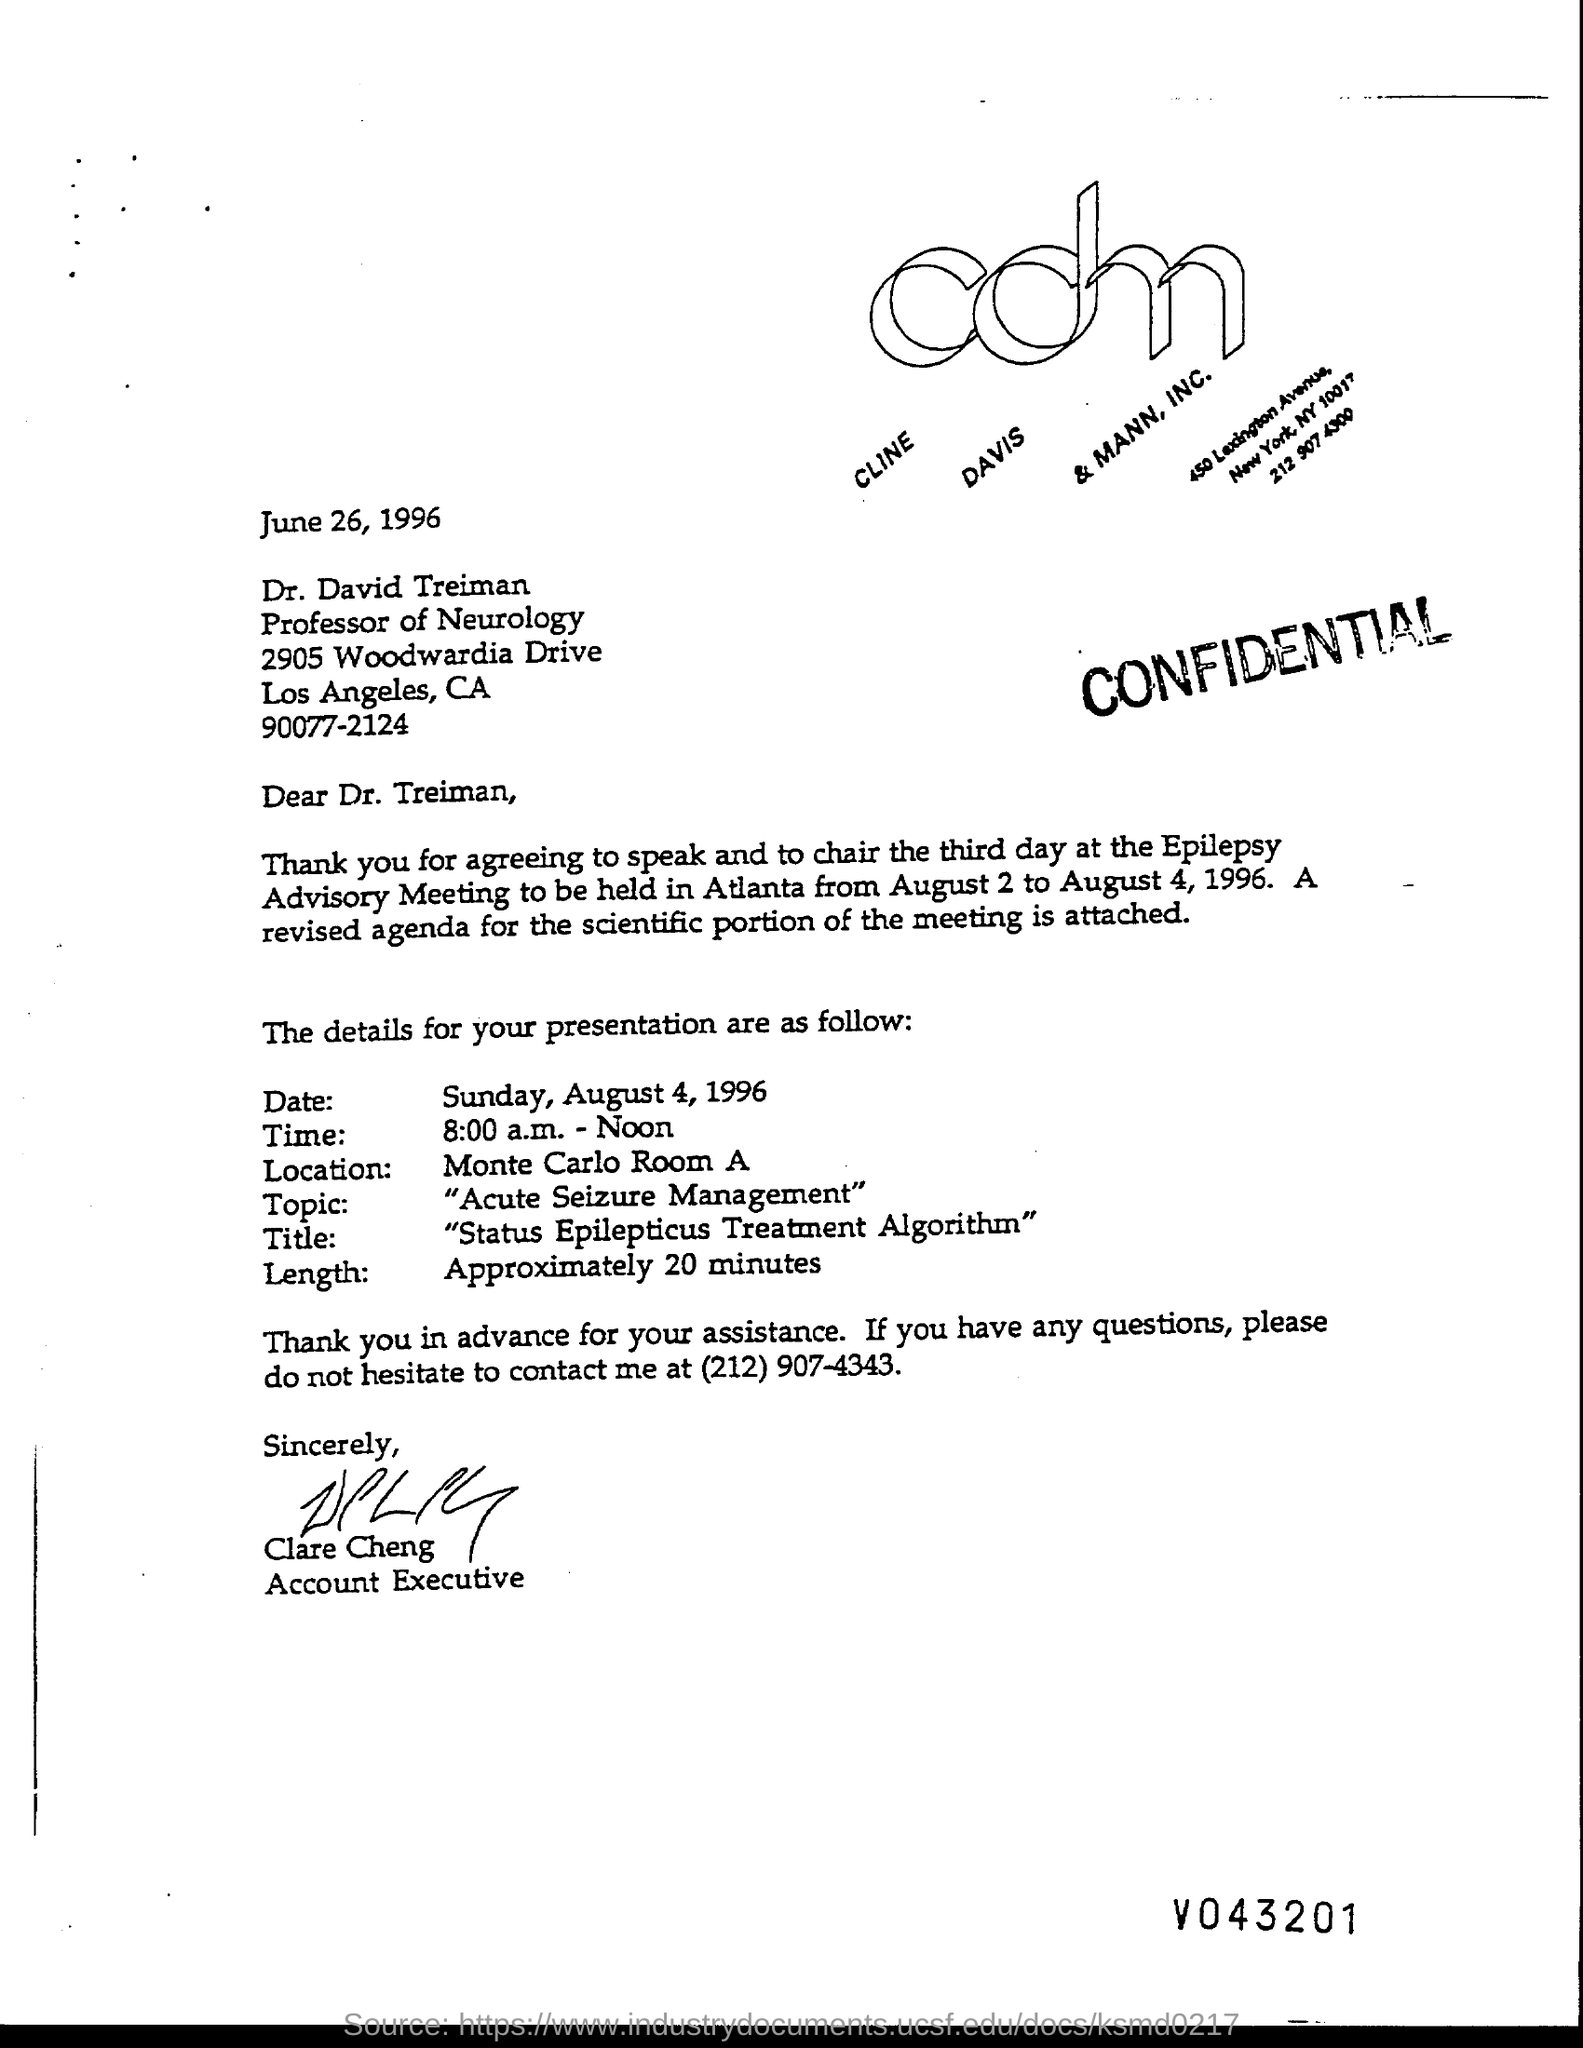What is the title of the presentation ?
Ensure brevity in your answer.  Status Epilepticus Treatment Algorithm. What is the length of the presentation?
Make the answer very short. APPROXIMATELY 20 MINUTES. Who is the accountant executive?
Your answer should be very brief. Clare Cheng. What is the topic of the presentation?
Keep it short and to the point. Acute Seizure Management. 